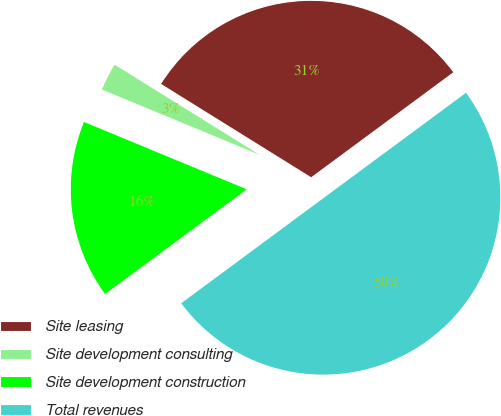<chart> <loc_0><loc_0><loc_500><loc_500><pie_chart><fcel>Site leasing<fcel>Site development consulting<fcel>Site development construction<fcel>Total revenues<nl><fcel>31.02%<fcel>2.61%<fcel>16.38%<fcel>50.0%<nl></chart> 